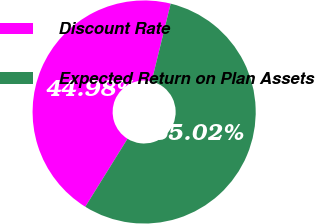<chart> <loc_0><loc_0><loc_500><loc_500><pie_chart><fcel>Discount Rate<fcel>Expected Return on Plan Assets<nl><fcel>44.98%<fcel>55.02%<nl></chart> 